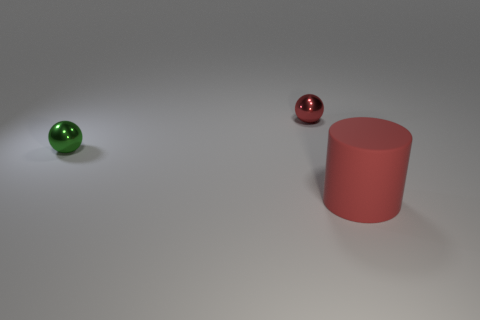Subtract all green balls. How many balls are left? 1 Subtract all balls. How many objects are left? 1 Subtract 2 balls. How many balls are left? 0 Add 1 small red metal things. How many small red metal things exist? 2 Add 3 big brown metal balls. How many objects exist? 6 Subtract 0 cyan cylinders. How many objects are left? 3 Subtract all red spheres. Subtract all brown cylinders. How many spheres are left? 1 Subtract all red blocks. How many green spheres are left? 1 Subtract all tiny shiny spheres. Subtract all large things. How many objects are left? 0 Add 2 big red cylinders. How many big red cylinders are left? 3 